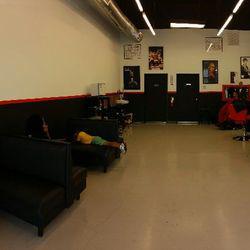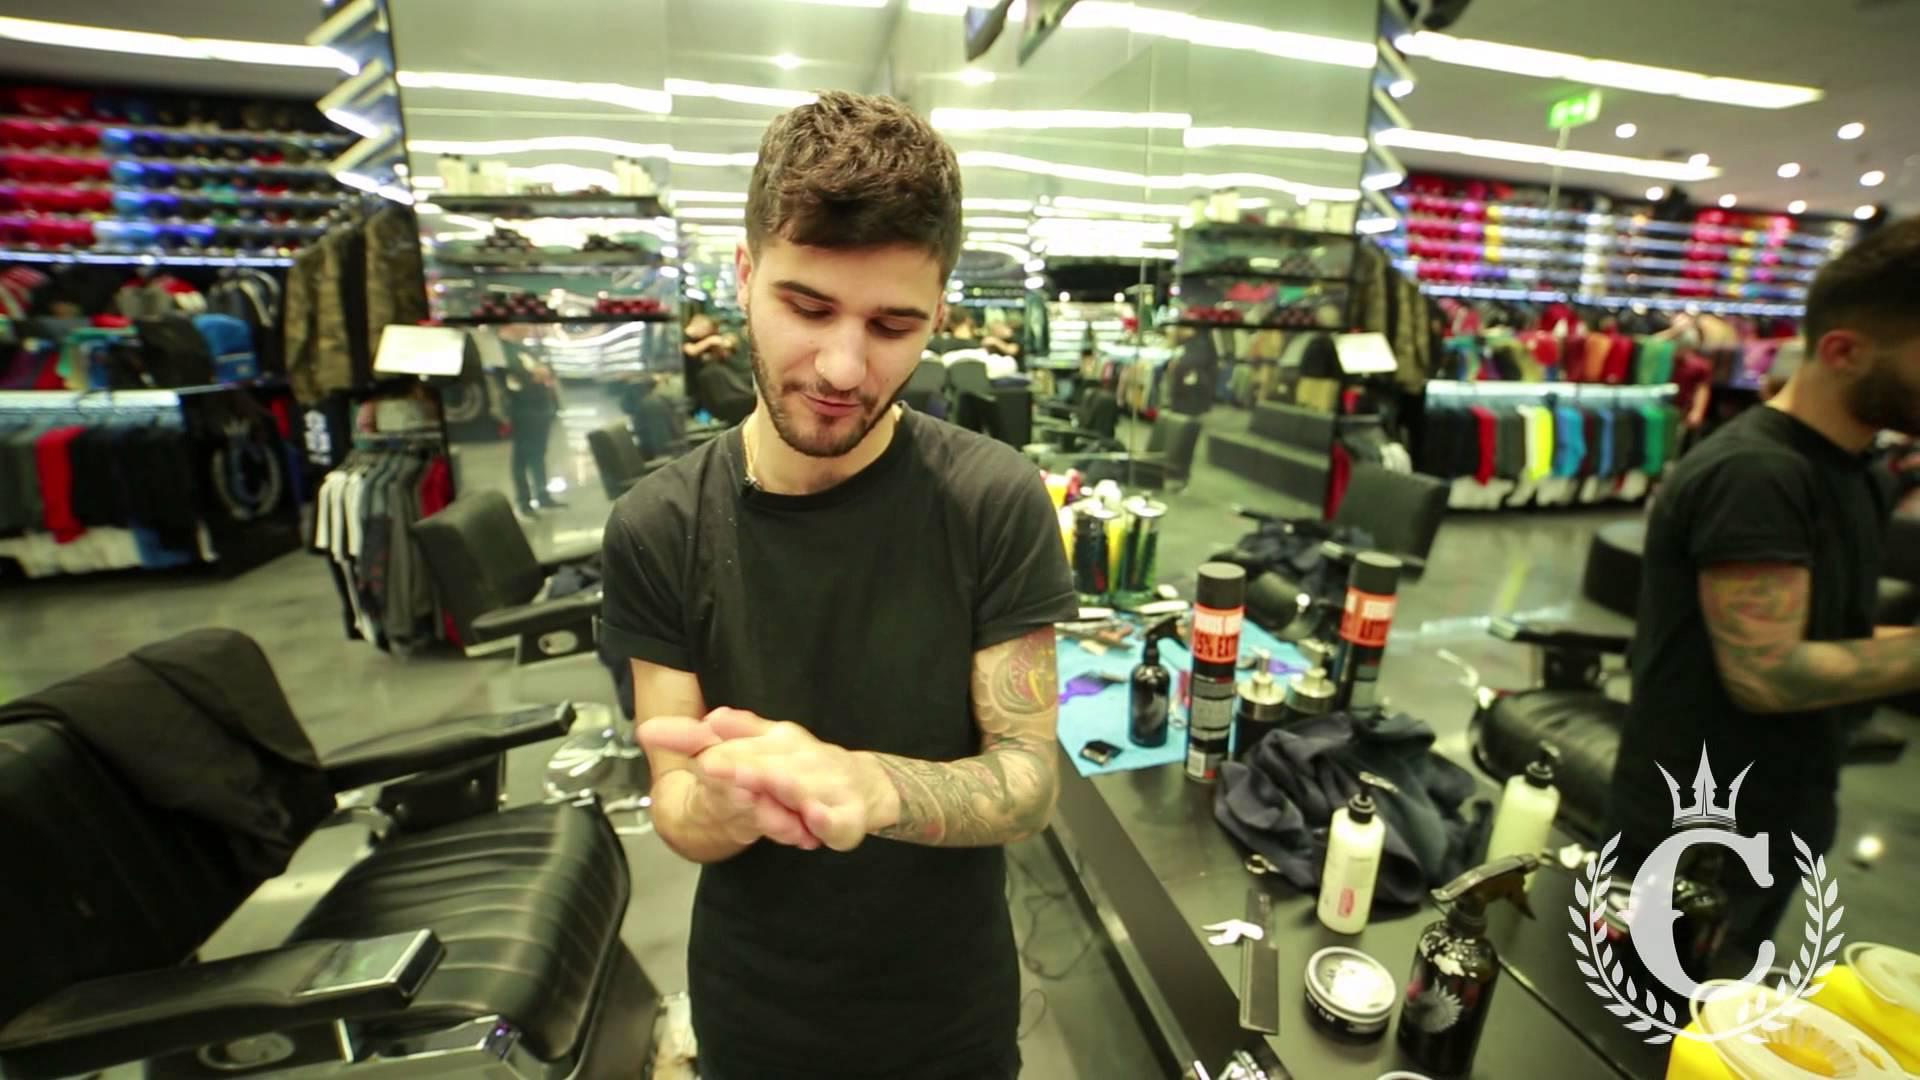The first image is the image on the left, the second image is the image on the right. Considering the images on both sides, is "An image shows a row of red and black barber chairs, without customers in the chairs in the foreground." valid? Answer yes or no. No. The first image is the image on the left, the second image is the image on the right. Assess this claim about the two images: "There are black seats in the left side of the shop in the image on the left.". Correct or not? Answer yes or no. Yes. 